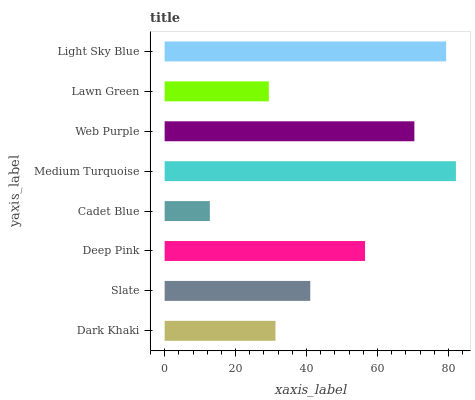Is Cadet Blue the minimum?
Answer yes or no. Yes. Is Medium Turquoise the maximum?
Answer yes or no. Yes. Is Slate the minimum?
Answer yes or no. No. Is Slate the maximum?
Answer yes or no. No. Is Slate greater than Dark Khaki?
Answer yes or no. Yes. Is Dark Khaki less than Slate?
Answer yes or no. Yes. Is Dark Khaki greater than Slate?
Answer yes or no. No. Is Slate less than Dark Khaki?
Answer yes or no. No. Is Deep Pink the high median?
Answer yes or no. Yes. Is Slate the low median?
Answer yes or no. Yes. Is Web Purple the high median?
Answer yes or no. No. Is Deep Pink the low median?
Answer yes or no. No. 